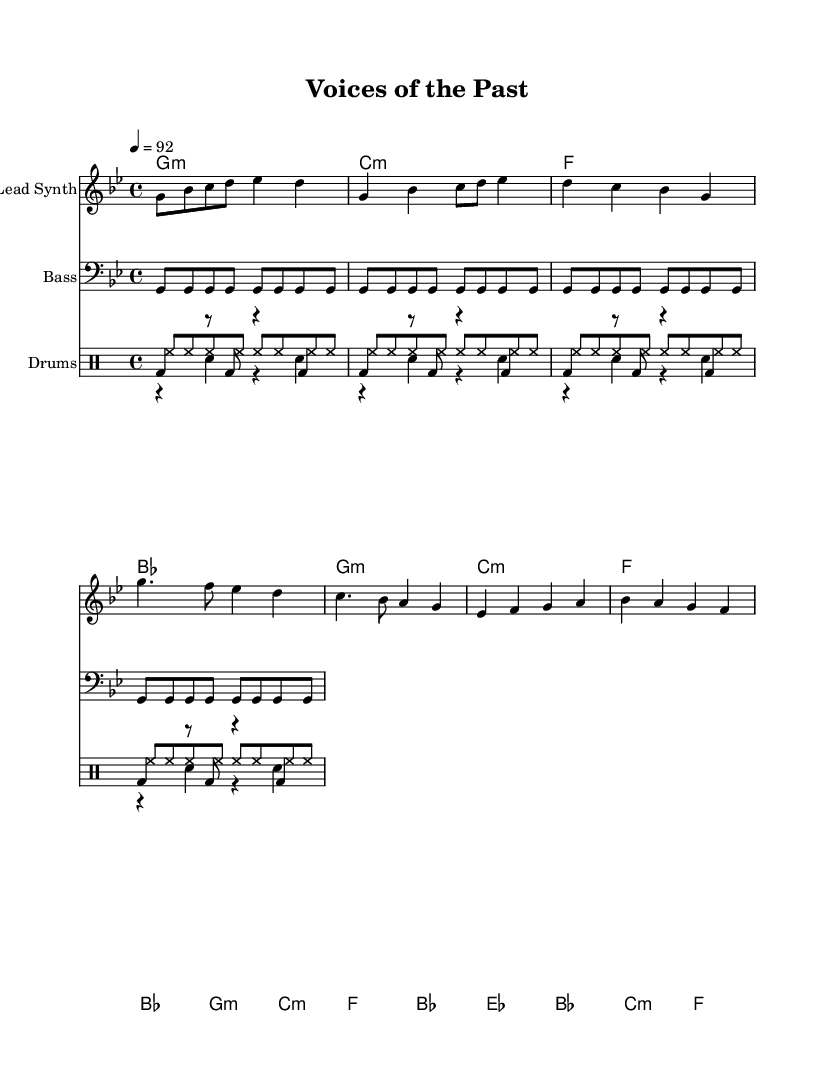what is the key signature of this music? The key signature is G minor, which has two flats (B♭ and E♭). This is indicated by the presence of the flat signs before the relevant notes in the staff.
Answer: G minor what is the time signature of this music? The time signature is 4/4, which means there are four beats per measure and a quarter note receives one beat. This is indicated at the beginning of the sheet music.
Answer: 4/4 what is the tempo of this music? The tempo marking indicates a speed of 92 beats per minute. This is stated at the beginning of the piece beneath the clef and key signature.
Answer: 92 how many measures are in the verse? There are four measures in the verse as indicated by the repeated section starting from measure five and ending at measure eight, which spans four distinct bars.
Answer: 4 what instruments are featured in this score? The instruments included are a lead synth, bass, and drums. This is identified by the labeled staves at the beginning of each section of the score.
Answer: Lead Synth, Bass, Drums how is the kick drum pattern structured in terms of notation? The kick drum pattern consists of repeated quarter notes, with rests in between them, as notated in the drum staff. This shows a rhythmic structure typical for hip hop beats, emphasizing the downbeat.
Answer: Repeated quarter notes with rests what form does the bridge section take compared to the verse? The bridge section introduces different melody notes and changes chord progression compared to the verse, providing contrast in the overall structure. The bridge is outlined by different pitches in the lead synth line.
Answer: Contrast in melody and chord progression 